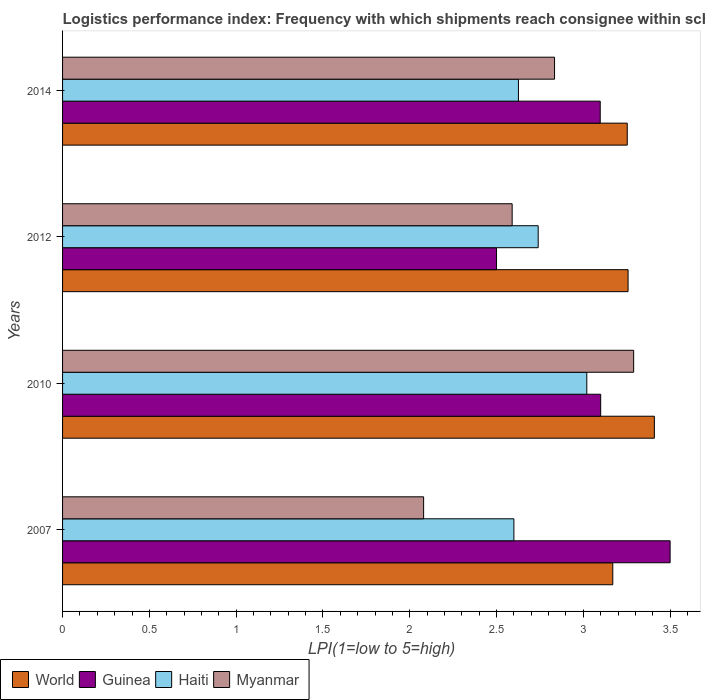How many different coloured bars are there?
Your response must be concise. 4. How many bars are there on the 2nd tick from the bottom?
Your answer should be compact. 4. What is the label of the 1st group of bars from the top?
Offer a very short reply. 2014. What is the logistics performance index in Haiti in 2012?
Ensure brevity in your answer.  2.74. Across all years, what is the maximum logistics performance index in Myanmar?
Provide a short and direct response. 3.29. What is the total logistics performance index in World in the graph?
Offer a terse response. 13.09. What is the difference between the logistics performance index in Guinea in 2007 and that in 2014?
Your answer should be compact. 0.4. What is the difference between the logistics performance index in Myanmar in 2010 and the logistics performance index in World in 2014?
Your response must be concise. 0.04. What is the average logistics performance index in Myanmar per year?
Your answer should be very brief. 2.7. In the year 2007, what is the difference between the logistics performance index in World and logistics performance index in Guinea?
Your answer should be very brief. -0.33. In how many years, is the logistics performance index in Haiti greater than 1.8 ?
Your answer should be very brief. 4. What is the ratio of the logistics performance index in Myanmar in 2007 to that in 2012?
Your answer should be compact. 0.8. Is the difference between the logistics performance index in World in 2010 and 2014 greater than the difference between the logistics performance index in Guinea in 2010 and 2014?
Your response must be concise. Yes. What is the difference between the highest and the second highest logistics performance index in Guinea?
Provide a succinct answer. 0.4. What is the difference between the highest and the lowest logistics performance index in Myanmar?
Your response must be concise. 1.21. What does the 3rd bar from the top in 2014 represents?
Ensure brevity in your answer.  Guinea. What does the 1st bar from the bottom in 2014 represents?
Provide a short and direct response. World. Are all the bars in the graph horizontal?
Keep it short and to the point. Yes. How many years are there in the graph?
Your response must be concise. 4. Does the graph contain any zero values?
Ensure brevity in your answer.  No. Does the graph contain grids?
Ensure brevity in your answer.  No. What is the title of the graph?
Offer a very short reply. Logistics performance index: Frequency with which shipments reach consignee within scheduled time. What is the label or title of the X-axis?
Offer a terse response. LPI(1=low to 5=high). What is the label or title of the Y-axis?
Your response must be concise. Years. What is the LPI(1=low to 5=high) in World in 2007?
Provide a succinct answer. 3.17. What is the LPI(1=low to 5=high) of Myanmar in 2007?
Make the answer very short. 2.08. What is the LPI(1=low to 5=high) in World in 2010?
Make the answer very short. 3.41. What is the LPI(1=low to 5=high) of Haiti in 2010?
Ensure brevity in your answer.  3.02. What is the LPI(1=low to 5=high) in Myanmar in 2010?
Your response must be concise. 3.29. What is the LPI(1=low to 5=high) in World in 2012?
Keep it short and to the point. 3.26. What is the LPI(1=low to 5=high) in Haiti in 2012?
Your answer should be compact. 2.74. What is the LPI(1=low to 5=high) in Myanmar in 2012?
Offer a very short reply. 2.59. What is the LPI(1=low to 5=high) in World in 2014?
Keep it short and to the point. 3.25. What is the LPI(1=low to 5=high) in Guinea in 2014?
Provide a succinct answer. 3.1. What is the LPI(1=low to 5=high) in Haiti in 2014?
Your answer should be very brief. 2.63. What is the LPI(1=low to 5=high) in Myanmar in 2014?
Provide a succinct answer. 2.83. Across all years, what is the maximum LPI(1=low to 5=high) in World?
Provide a succinct answer. 3.41. Across all years, what is the maximum LPI(1=low to 5=high) in Guinea?
Your answer should be compact. 3.5. Across all years, what is the maximum LPI(1=low to 5=high) of Haiti?
Provide a succinct answer. 3.02. Across all years, what is the maximum LPI(1=low to 5=high) of Myanmar?
Your answer should be compact. 3.29. Across all years, what is the minimum LPI(1=low to 5=high) in World?
Ensure brevity in your answer.  3.17. Across all years, what is the minimum LPI(1=low to 5=high) in Guinea?
Offer a terse response. 2.5. Across all years, what is the minimum LPI(1=low to 5=high) of Haiti?
Your answer should be compact. 2.6. Across all years, what is the minimum LPI(1=low to 5=high) of Myanmar?
Your answer should be compact. 2.08. What is the total LPI(1=low to 5=high) of World in the graph?
Provide a succinct answer. 13.09. What is the total LPI(1=low to 5=high) of Guinea in the graph?
Make the answer very short. 12.2. What is the total LPI(1=low to 5=high) in Haiti in the graph?
Your response must be concise. 10.99. What is the total LPI(1=low to 5=high) of Myanmar in the graph?
Your response must be concise. 10.79. What is the difference between the LPI(1=low to 5=high) of World in 2007 and that in 2010?
Your response must be concise. -0.24. What is the difference between the LPI(1=low to 5=high) of Haiti in 2007 and that in 2010?
Provide a short and direct response. -0.42. What is the difference between the LPI(1=low to 5=high) of Myanmar in 2007 and that in 2010?
Your answer should be very brief. -1.21. What is the difference between the LPI(1=low to 5=high) in World in 2007 and that in 2012?
Your response must be concise. -0.09. What is the difference between the LPI(1=low to 5=high) in Haiti in 2007 and that in 2012?
Provide a succinct answer. -0.14. What is the difference between the LPI(1=low to 5=high) of Myanmar in 2007 and that in 2012?
Keep it short and to the point. -0.51. What is the difference between the LPI(1=low to 5=high) in World in 2007 and that in 2014?
Give a very brief answer. -0.08. What is the difference between the LPI(1=low to 5=high) in Guinea in 2007 and that in 2014?
Your response must be concise. 0.4. What is the difference between the LPI(1=low to 5=high) in Haiti in 2007 and that in 2014?
Give a very brief answer. -0.03. What is the difference between the LPI(1=low to 5=high) of Myanmar in 2007 and that in 2014?
Keep it short and to the point. -0.75. What is the difference between the LPI(1=low to 5=high) in World in 2010 and that in 2012?
Offer a very short reply. 0.15. What is the difference between the LPI(1=low to 5=high) of Guinea in 2010 and that in 2012?
Your answer should be very brief. 0.6. What is the difference between the LPI(1=low to 5=high) of Haiti in 2010 and that in 2012?
Provide a succinct answer. 0.28. What is the difference between the LPI(1=low to 5=high) in World in 2010 and that in 2014?
Keep it short and to the point. 0.16. What is the difference between the LPI(1=low to 5=high) of Guinea in 2010 and that in 2014?
Offer a very short reply. 0. What is the difference between the LPI(1=low to 5=high) in Haiti in 2010 and that in 2014?
Offer a terse response. 0.39. What is the difference between the LPI(1=low to 5=high) in Myanmar in 2010 and that in 2014?
Offer a very short reply. 0.46. What is the difference between the LPI(1=low to 5=high) in World in 2012 and that in 2014?
Keep it short and to the point. 0. What is the difference between the LPI(1=low to 5=high) of Guinea in 2012 and that in 2014?
Your response must be concise. -0.6. What is the difference between the LPI(1=low to 5=high) of Haiti in 2012 and that in 2014?
Your response must be concise. 0.11. What is the difference between the LPI(1=low to 5=high) in Myanmar in 2012 and that in 2014?
Ensure brevity in your answer.  -0.24. What is the difference between the LPI(1=low to 5=high) in World in 2007 and the LPI(1=low to 5=high) in Guinea in 2010?
Provide a short and direct response. 0.07. What is the difference between the LPI(1=low to 5=high) in World in 2007 and the LPI(1=low to 5=high) in Haiti in 2010?
Provide a succinct answer. 0.15. What is the difference between the LPI(1=low to 5=high) in World in 2007 and the LPI(1=low to 5=high) in Myanmar in 2010?
Your answer should be very brief. -0.12. What is the difference between the LPI(1=low to 5=high) in Guinea in 2007 and the LPI(1=low to 5=high) in Haiti in 2010?
Offer a terse response. 0.48. What is the difference between the LPI(1=low to 5=high) in Guinea in 2007 and the LPI(1=low to 5=high) in Myanmar in 2010?
Offer a very short reply. 0.21. What is the difference between the LPI(1=low to 5=high) in Haiti in 2007 and the LPI(1=low to 5=high) in Myanmar in 2010?
Keep it short and to the point. -0.69. What is the difference between the LPI(1=low to 5=high) in World in 2007 and the LPI(1=low to 5=high) in Guinea in 2012?
Make the answer very short. 0.67. What is the difference between the LPI(1=low to 5=high) in World in 2007 and the LPI(1=low to 5=high) in Haiti in 2012?
Make the answer very short. 0.43. What is the difference between the LPI(1=low to 5=high) of World in 2007 and the LPI(1=low to 5=high) of Myanmar in 2012?
Your answer should be compact. 0.58. What is the difference between the LPI(1=low to 5=high) of Guinea in 2007 and the LPI(1=low to 5=high) of Haiti in 2012?
Make the answer very short. 0.76. What is the difference between the LPI(1=low to 5=high) of Guinea in 2007 and the LPI(1=low to 5=high) of Myanmar in 2012?
Make the answer very short. 0.91. What is the difference between the LPI(1=low to 5=high) in World in 2007 and the LPI(1=low to 5=high) in Guinea in 2014?
Your answer should be compact. 0.07. What is the difference between the LPI(1=low to 5=high) in World in 2007 and the LPI(1=low to 5=high) in Haiti in 2014?
Keep it short and to the point. 0.54. What is the difference between the LPI(1=low to 5=high) of World in 2007 and the LPI(1=low to 5=high) of Myanmar in 2014?
Provide a short and direct response. 0.34. What is the difference between the LPI(1=low to 5=high) of Guinea in 2007 and the LPI(1=low to 5=high) of Haiti in 2014?
Give a very brief answer. 0.87. What is the difference between the LPI(1=low to 5=high) of Guinea in 2007 and the LPI(1=low to 5=high) of Myanmar in 2014?
Keep it short and to the point. 0.67. What is the difference between the LPI(1=low to 5=high) of Haiti in 2007 and the LPI(1=low to 5=high) of Myanmar in 2014?
Your answer should be very brief. -0.23. What is the difference between the LPI(1=low to 5=high) of World in 2010 and the LPI(1=low to 5=high) of Guinea in 2012?
Make the answer very short. 0.91. What is the difference between the LPI(1=low to 5=high) of World in 2010 and the LPI(1=low to 5=high) of Haiti in 2012?
Your answer should be very brief. 0.67. What is the difference between the LPI(1=low to 5=high) in World in 2010 and the LPI(1=low to 5=high) in Myanmar in 2012?
Keep it short and to the point. 0.82. What is the difference between the LPI(1=low to 5=high) in Guinea in 2010 and the LPI(1=low to 5=high) in Haiti in 2012?
Offer a terse response. 0.36. What is the difference between the LPI(1=low to 5=high) in Guinea in 2010 and the LPI(1=low to 5=high) in Myanmar in 2012?
Offer a very short reply. 0.51. What is the difference between the LPI(1=low to 5=high) in Haiti in 2010 and the LPI(1=low to 5=high) in Myanmar in 2012?
Make the answer very short. 0.43. What is the difference between the LPI(1=low to 5=high) in World in 2010 and the LPI(1=low to 5=high) in Guinea in 2014?
Ensure brevity in your answer.  0.31. What is the difference between the LPI(1=low to 5=high) of World in 2010 and the LPI(1=low to 5=high) of Haiti in 2014?
Your answer should be compact. 0.78. What is the difference between the LPI(1=low to 5=high) of World in 2010 and the LPI(1=low to 5=high) of Myanmar in 2014?
Offer a terse response. 0.57. What is the difference between the LPI(1=low to 5=high) of Guinea in 2010 and the LPI(1=low to 5=high) of Haiti in 2014?
Make the answer very short. 0.47. What is the difference between the LPI(1=low to 5=high) in Guinea in 2010 and the LPI(1=low to 5=high) in Myanmar in 2014?
Your answer should be very brief. 0.27. What is the difference between the LPI(1=low to 5=high) in Haiti in 2010 and the LPI(1=low to 5=high) in Myanmar in 2014?
Your answer should be compact. 0.19. What is the difference between the LPI(1=low to 5=high) in World in 2012 and the LPI(1=low to 5=high) in Guinea in 2014?
Keep it short and to the point. 0.16. What is the difference between the LPI(1=low to 5=high) of World in 2012 and the LPI(1=low to 5=high) of Haiti in 2014?
Give a very brief answer. 0.63. What is the difference between the LPI(1=low to 5=high) of World in 2012 and the LPI(1=low to 5=high) of Myanmar in 2014?
Your response must be concise. 0.42. What is the difference between the LPI(1=low to 5=high) of Guinea in 2012 and the LPI(1=low to 5=high) of Haiti in 2014?
Offer a terse response. -0.13. What is the difference between the LPI(1=low to 5=high) in Guinea in 2012 and the LPI(1=low to 5=high) in Myanmar in 2014?
Your response must be concise. -0.33. What is the difference between the LPI(1=low to 5=high) of Haiti in 2012 and the LPI(1=low to 5=high) of Myanmar in 2014?
Keep it short and to the point. -0.09. What is the average LPI(1=low to 5=high) in World per year?
Your response must be concise. 3.27. What is the average LPI(1=low to 5=high) of Guinea per year?
Make the answer very short. 3.05. What is the average LPI(1=low to 5=high) of Haiti per year?
Offer a terse response. 2.75. What is the average LPI(1=low to 5=high) of Myanmar per year?
Provide a short and direct response. 2.7. In the year 2007, what is the difference between the LPI(1=low to 5=high) of World and LPI(1=low to 5=high) of Guinea?
Make the answer very short. -0.33. In the year 2007, what is the difference between the LPI(1=low to 5=high) in World and LPI(1=low to 5=high) in Haiti?
Provide a short and direct response. 0.57. In the year 2007, what is the difference between the LPI(1=low to 5=high) in World and LPI(1=low to 5=high) in Myanmar?
Your answer should be compact. 1.09. In the year 2007, what is the difference between the LPI(1=low to 5=high) in Guinea and LPI(1=low to 5=high) in Myanmar?
Make the answer very short. 1.42. In the year 2007, what is the difference between the LPI(1=low to 5=high) in Haiti and LPI(1=low to 5=high) in Myanmar?
Your answer should be compact. 0.52. In the year 2010, what is the difference between the LPI(1=low to 5=high) in World and LPI(1=low to 5=high) in Guinea?
Provide a succinct answer. 0.31. In the year 2010, what is the difference between the LPI(1=low to 5=high) of World and LPI(1=low to 5=high) of Haiti?
Provide a succinct answer. 0.39. In the year 2010, what is the difference between the LPI(1=low to 5=high) in World and LPI(1=low to 5=high) in Myanmar?
Give a very brief answer. 0.12. In the year 2010, what is the difference between the LPI(1=low to 5=high) in Guinea and LPI(1=low to 5=high) in Myanmar?
Provide a succinct answer. -0.19. In the year 2010, what is the difference between the LPI(1=low to 5=high) of Haiti and LPI(1=low to 5=high) of Myanmar?
Your response must be concise. -0.27. In the year 2012, what is the difference between the LPI(1=low to 5=high) of World and LPI(1=low to 5=high) of Guinea?
Offer a terse response. 0.76. In the year 2012, what is the difference between the LPI(1=low to 5=high) in World and LPI(1=low to 5=high) in Haiti?
Your answer should be compact. 0.52. In the year 2012, what is the difference between the LPI(1=low to 5=high) of World and LPI(1=low to 5=high) of Myanmar?
Your answer should be very brief. 0.67. In the year 2012, what is the difference between the LPI(1=low to 5=high) of Guinea and LPI(1=low to 5=high) of Haiti?
Offer a terse response. -0.24. In the year 2012, what is the difference between the LPI(1=low to 5=high) in Guinea and LPI(1=low to 5=high) in Myanmar?
Offer a very short reply. -0.09. In the year 2014, what is the difference between the LPI(1=low to 5=high) of World and LPI(1=low to 5=high) of Guinea?
Ensure brevity in your answer.  0.16. In the year 2014, what is the difference between the LPI(1=low to 5=high) in World and LPI(1=low to 5=high) in Haiti?
Ensure brevity in your answer.  0.63. In the year 2014, what is the difference between the LPI(1=low to 5=high) in World and LPI(1=low to 5=high) in Myanmar?
Ensure brevity in your answer.  0.42. In the year 2014, what is the difference between the LPI(1=low to 5=high) in Guinea and LPI(1=low to 5=high) in Haiti?
Make the answer very short. 0.47. In the year 2014, what is the difference between the LPI(1=low to 5=high) of Guinea and LPI(1=low to 5=high) of Myanmar?
Make the answer very short. 0.26. In the year 2014, what is the difference between the LPI(1=low to 5=high) in Haiti and LPI(1=low to 5=high) in Myanmar?
Your response must be concise. -0.21. What is the ratio of the LPI(1=low to 5=high) of World in 2007 to that in 2010?
Your answer should be very brief. 0.93. What is the ratio of the LPI(1=low to 5=high) of Guinea in 2007 to that in 2010?
Provide a succinct answer. 1.13. What is the ratio of the LPI(1=low to 5=high) of Haiti in 2007 to that in 2010?
Offer a terse response. 0.86. What is the ratio of the LPI(1=low to 5=high) in Myanmar in 2007 to that in 2010?
Offer a very short reply. 0.63. What is the ratio of the LPI(1=low to 5=high) of World in 2007 to that in 2012?
Offer a very short reply. 0.97. What is the ratio of the LPI(1=low to 5=high) of Haiti in 2007 to that in 2012?
Provide a short and direct response. 0.95. What is the ratio of the LPI(1=low to 5=high) of Myanmar in 2007 to that in 2012?
Ensure brevity in your answer.  0.8. What is the ratio of the LPI(1=low to 5=high) of World in 2007 to that in 2014?
Your response must be concise. 0.97. What is the ratio of the LPI(1=low to 5=high) in Guinea in 2007 to that in 2014?
Offer a very short reply. 1.13. What is the ratio of the LPI(1=low to 5=high) of Myanmar in 2007 to that in 2014?
Your answer should be compact. 0.73. What is the ratio of the LPI(1=low to 5=high) in World in 2010 to that in 2012?
Your response must be concise. 1.05. What is the ratio of the LPI(1=low to 5=high) in Guinea in 2010 to that in 2012?
Keep it short and to the point. 1.24. What is the ratio of the LPI(1=low to 5=high) in Haiti in 2010 to that in 2012?
Provide a succinct answer. 1.1. What is the ratio of the LPI(1=low to 5=high) in Myanmar in 2010 to that in 2012?
Provide a succinct answer. 1.27. What is the ratio of the LPI(1=low to 5=high) in World in 2010 to that in 2014?
Give a very brief answer. 1.05. What is the ratio of the LPI(1=low to 5=high) of Guinea in 2010 to that in 2014?
Provide a succinct answer. 1. What is the ratio of the LPI(1=low to 5=high) of Haiti in 2010 to that in 2014?
Offer a terse response. 1.15. What is the ratio of the LPI(1=low to 5=high) of Myanmar in 2010 to that in 2014?
Offer a terse response. 1.16. What is the ratio of the LPI(1=low to 5=high) of World in 2012 to that in 2014?
Provide a short and direct response. 1. What is the ratio of the LPI(1=low to 5=high) in Guinea in 2012 to that in 2014?
Keep it short and to the point. 0.81. What is the ratio of the LPI(1=low to 5=high) in Haiti in 2012 to that in 2014?
Your response must be concise. 1.04. What is the ratio of the LPI(1=low to 5=high) of Myanmar in 2012 to that in 2014?
Your response must be concise. 0.91. What is the difference between the highest and the second highest LPI(1=low to 5=high) of World?
Your answer should be compact. 0.15. What is the difference between the highest and the second highest LPI(1=low to 5=high) of Guinea?
Offer a terse response. 0.4. What is the difference between the highest and the second highest LPI(1=low to 5=high) in Haiti?
Keep it short and to the point. 0.28. What is the difference between the highest and the second highest LPI(1=low to 5=high) in Myanmar?
Give a very brief answer. 0.46. What is the difference between the highest and the lowest LPI(1=low to 5=high) in World?
Keep it short and to the point. 0.24. What is the difference between the highest and the lowest LPI(1=low to 5=high) in Haiti?
Provide a succinct answer. 0.42. What is the difference between the highest and the lowest LPI(1=low to 5=high) in Myanmar?
Your answer should be compact. 1.21. 